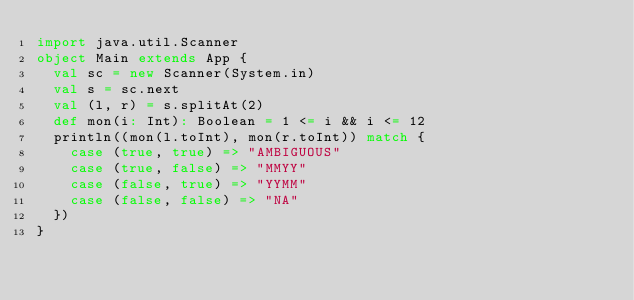<code> <loc_0><loc_0><loc_500><loc_500><_Scala_>import java.util.Scanner
object Main extends App {
  val sc = new Scanner(System.in)
  val s = sc.next
  val (l, r) = s.splitAt(2)
  def mon(i: Int): Boolean = 1 <= i && i <= 12
  println((mon(l.toInt), mon(r.toInt)) match {
    case (true, true) => "AMBIGUOUS"
    case (true, false) => "MMYY"
    case (false, true) => "YYMM"
    case (false, false) => "NA"
  })
}</code> 